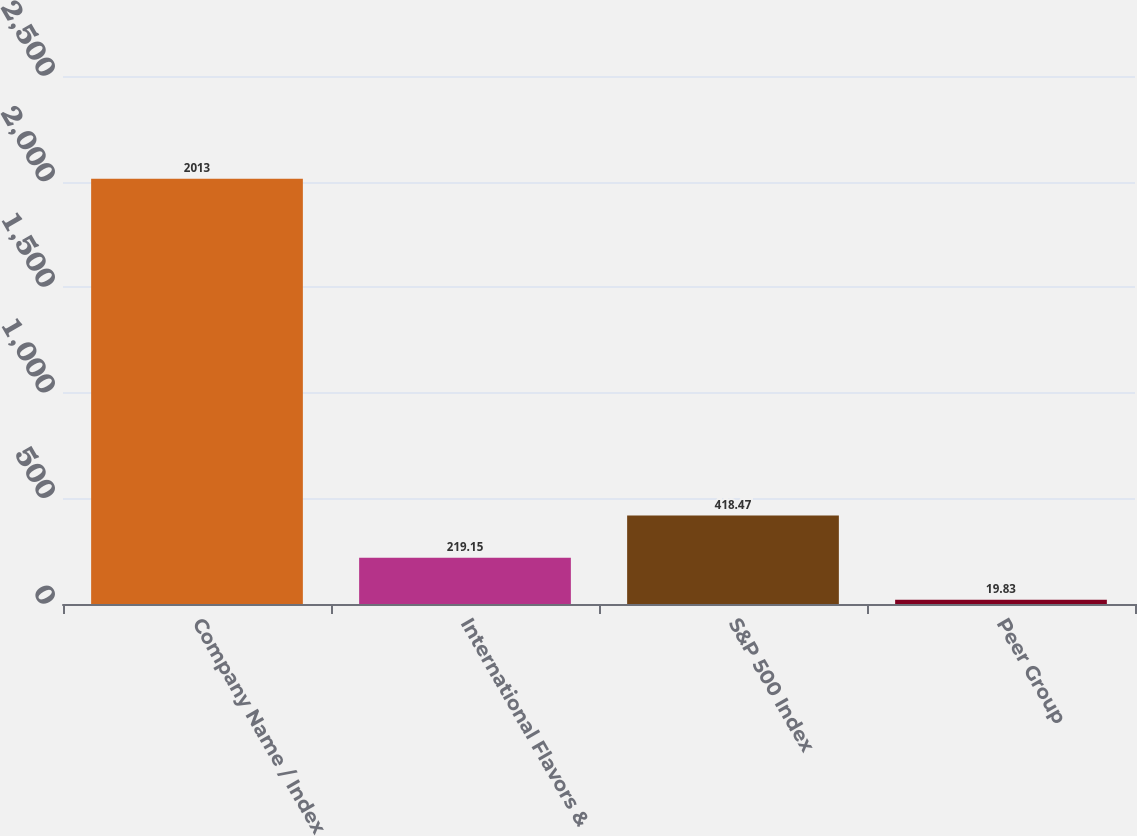Convert chart to OTSL. <chart><loc_0><loc_0><loc_500><loc_500><bar_chart><fcel>Company Name / Index<fcel>International Flavors &<fcel>S&P 500 Index<fcel>Peer Group<nl><fcel>2013<fcel>219.15<fcel>418.47<fcel>19.83<nl></chart> 